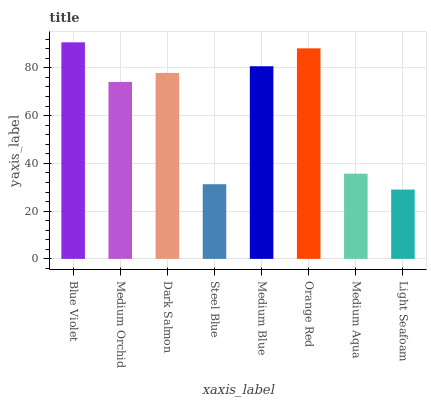Is Light Seafoam the minimum?
Answer yes or no. Yes. Is Blue Violet the maximum?
Answer yes or no. Yes. Is Medium Orchid the minimum?
Answer yes or no. No. Is Medium Orchid the maximum?
Answer yes or no. No. Is Blue Violet greater than Medium Orchid?
Answer yes or no. Yes. Is Medium Orchid less than Blue Violet?
Answer yes or no. Yes. Is Medium Orchid greater than Blue Violet?
Answer yes or no. No. Is Blue Violet less than Medium Orchid?
Answer yes or no. No. Is Dark Salmon the high median?
Answer yes or no. Yes. Is Medium Orchid the low median?
Answer yes or no. Yes. Is Orange Red the high median?
Answer yes or no. No. Is Orange Red the low median?
Answer yes or no. No. 